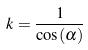Convert formula to latex. <formula><loc_0><loc_0><loc_500><loc_500>k = \frac { 1 } { \cos ( \alpha ) }</formula> 